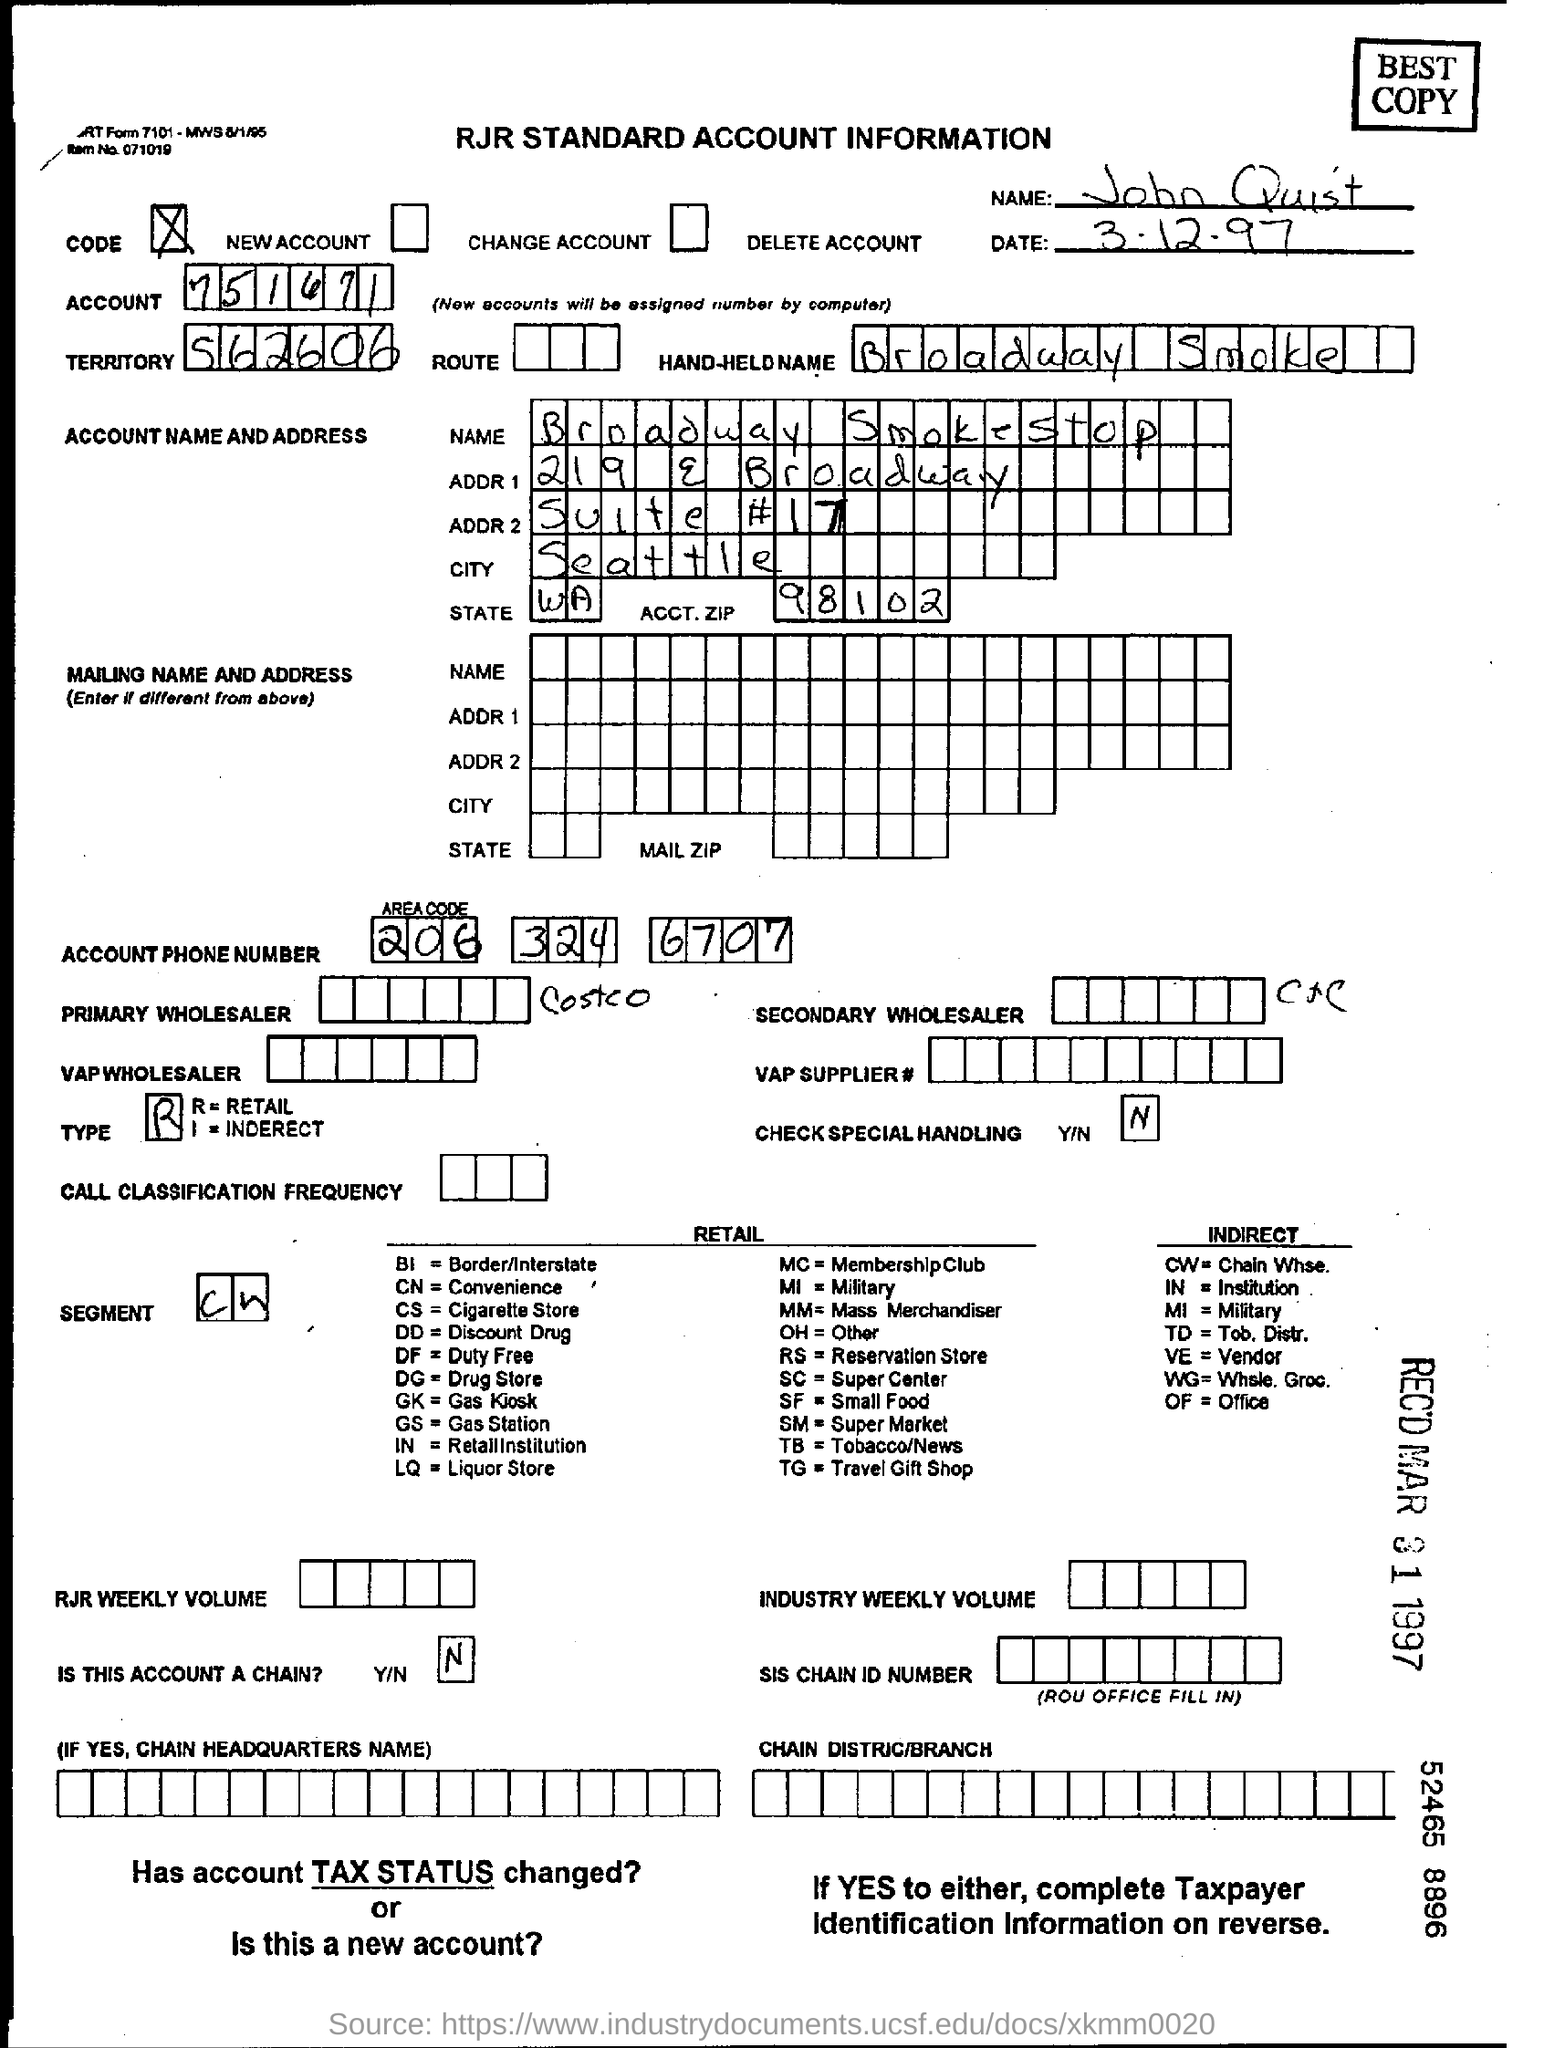Identify some key points in this picture. The hand-held NAME mentioned is Broadway Smoke. John Quist is the name mentioned in the form. 